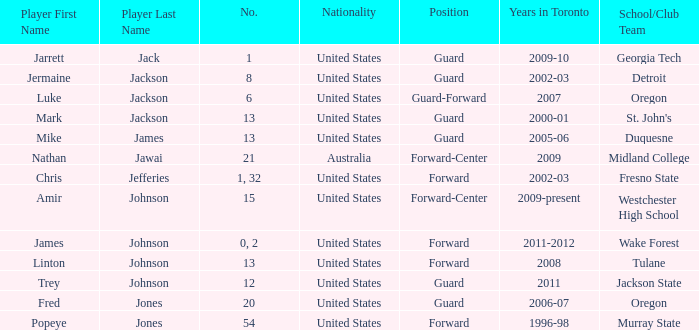Who are all of the players on the Westchester High School club team? Amir Johnson. 